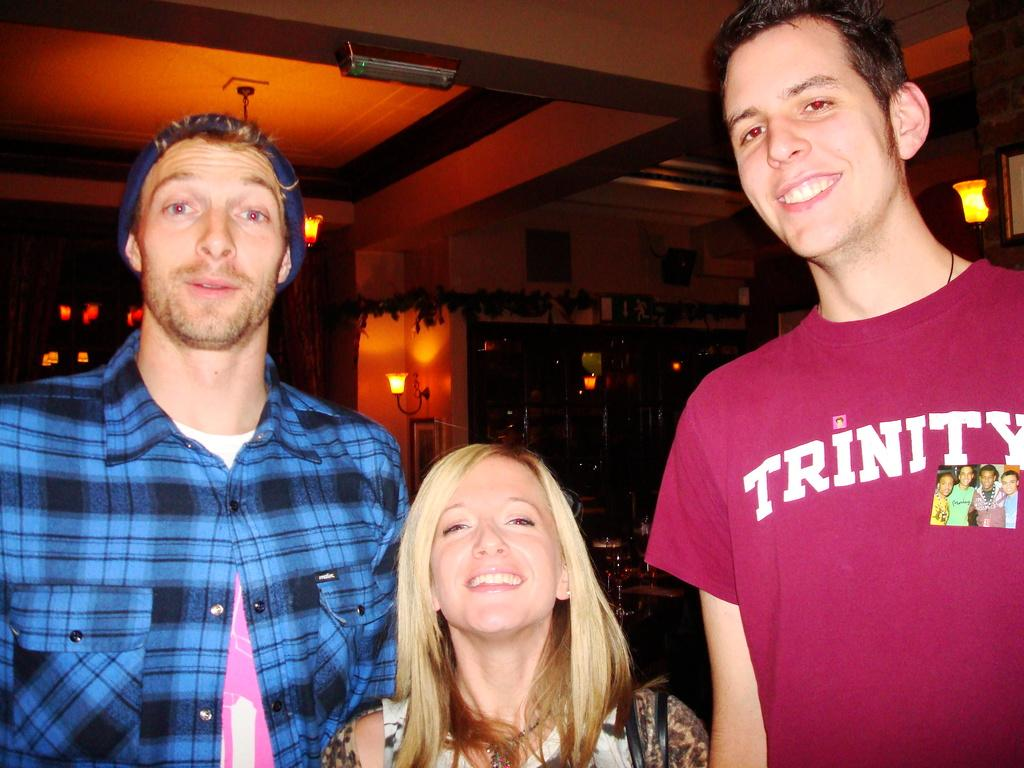How many people are in the image? There are three persons in the image. What is the facial expression of the persons in the image? The persons are smiling. What can be seen in the background of the image? There are glasses with liquids, lights, a wall, a frame, decorative objects, and a ceiling visible in the background. Can you describe the decorative objects in the background? The decorative objects in the background are not specified, so it is not possible to describe them. What type of stamp can be seen on the head of one of the persons in the image? There is no stamp visible on the head of any person in the image. 